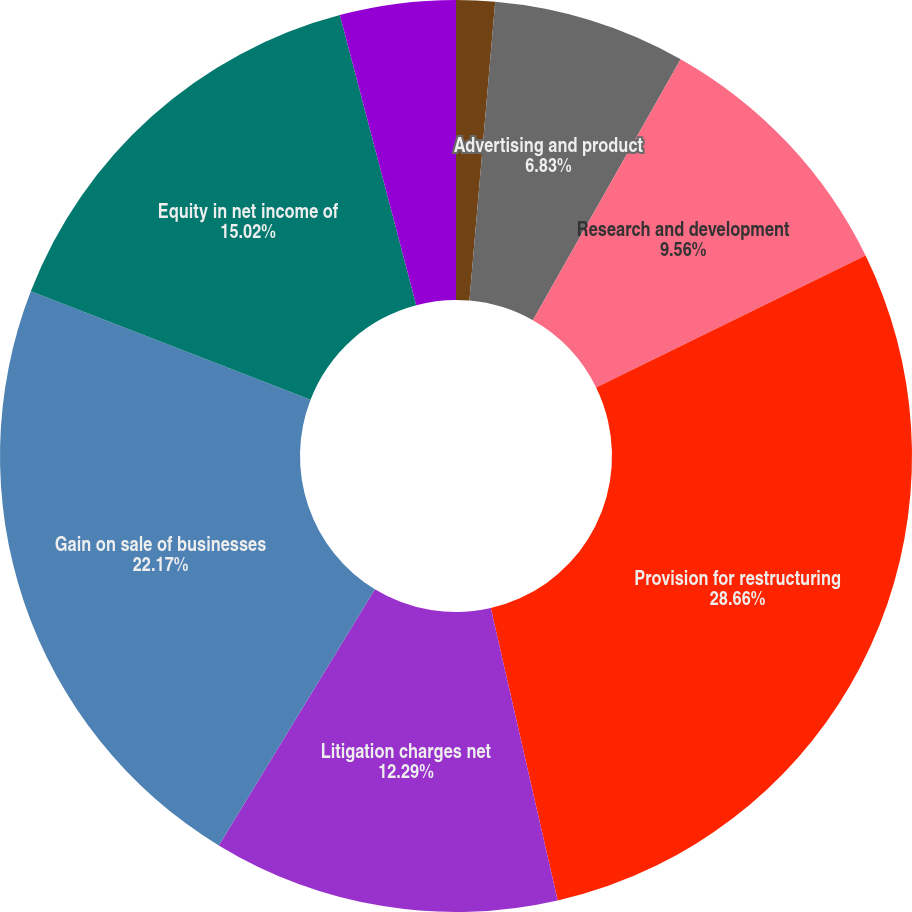<chart> <loc_0><loc_0><loc_500><loc_500><pie_chart><fcel>Marketing selling and<fcel>Advertising and product<fcel>Research and development<fcel>Provision for restructuring<fcel>Litigation charges net<fcel>Gain on sale of businesses<fcel>Equity in net income of<fcel>Total Expenses net<nl><fcel>1.37%<fcel>6.83%<fcel>9.56%<fcel>28.67%<fcel>12.29%<fcel>22.18%<fcel>15.02%<fcel>4.1%<nl></chart> 